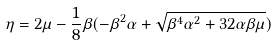<formula> <loc_0><loc_0><loc_500><loc_500>\eta = 2 \mu - \frac { 1 } { 8 } \beta ( - \beta ^ { 2 } \alpha + \sqrt { \beta ^ { 4 } \alpha ^ { 2 } + 3 2 \alpha \beta \mu } )</formula> 